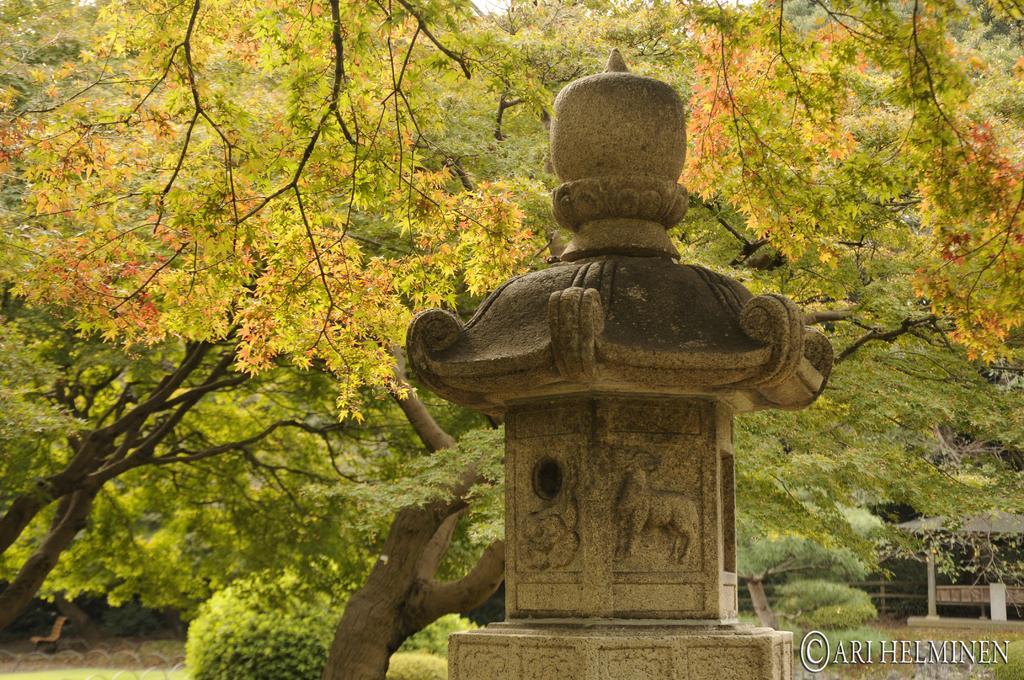Could you give a brief overview of what you see in this image? In this image there is a stone pillar in the middle. On the pillar there are some sculptures. In the background there are trees. 